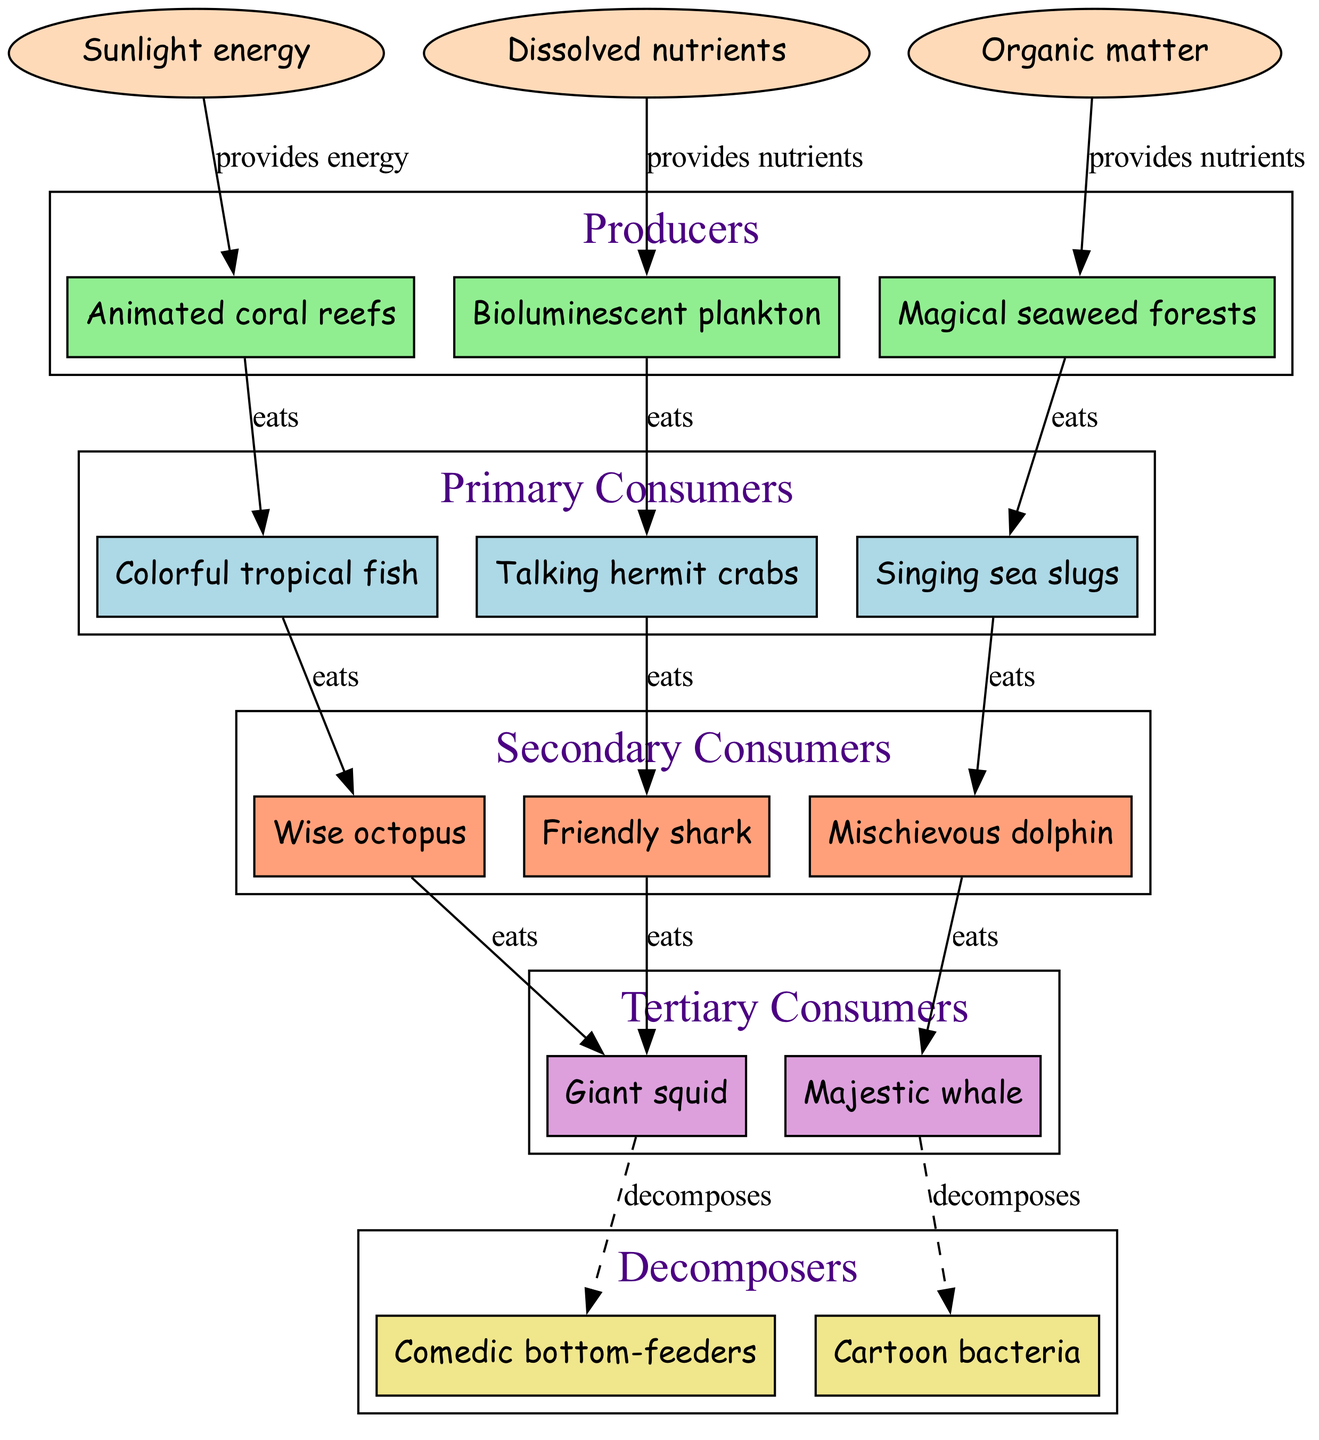What are the producers in this food chain? The producers are the organisms that initiate the food chain, providing energy for the primary consumers. Looking at the diagram, the producers listed include Animated coral reefs, Magical seaweed forests, and Bioluminescent plankton.
Answer: Animated coral reefs, Magical seaweed forests, Bioluminescent plankton How many primary consumers are there? By counting the nodes in the primary consumers' section of the diagram, we find there are three organisms: Colorful tropical fish, Singing sea slugs, and Talking hermit crabs.
Answer: 3 Who is the primary consumer that eats Singing sea slugs? The edge connecting Singing sea slugs to another organism indicates which primary consumer eats them. The edge leads to Mischievous dolphin, which is the secondary consumer consuming the Singing sea slugs.
Answer: Mischievous dolphin Which organism is decomposed by Cartoon bacteria? Looking at the dashed edge connecting the organisms, we see that Majestic whale flows into Cartoon bacteria as it decomposes, indicating that Cartoon bacteria decomposes the Majestic whale.
Answer: Majestic whale What provides energy to Animated coral reefs? The flow of nutrient energy is shown by the edge leading into Animated coral reefs, which comes from Sunlight energy, demonstrating that it is the source of energy for the producers.
Answer: Sunlight energy Which organisms are secondary consumers in this diagram? By observing the section for secondary consumers, we identify three organisms: Wise octopus, Mischievous dolphin, and Friendly shark, which are all consumers that eat primary consumers.
Answer: Wise octopus, Mischievous dolphin, Friendly shark How many tertiary consumers are there? The tertiary consumers section shows two organisms, Giant squid and Majestic whale. Therefore, to find the total number of tertiary consumers, we simply count these two organisms.
Answer: 2 What is the relationship between Friendly shark and Giant squid? The diagram indicates that Friendly shark consumes Giant squid, which is represented by a directed edge pointing from Friendly shark to Giant squid, illustrating their predator-prey relationship.
Answer: eats Which nutrient flow is linked to Bioluminescent plankton? The diagram’s nutrient flows indicate that Bioluminescent plankton is fed by dissolved nutrients, which comes from the edge directed toward it, highlighting its source of nutrients.
Answer: Dissolved nutrients 